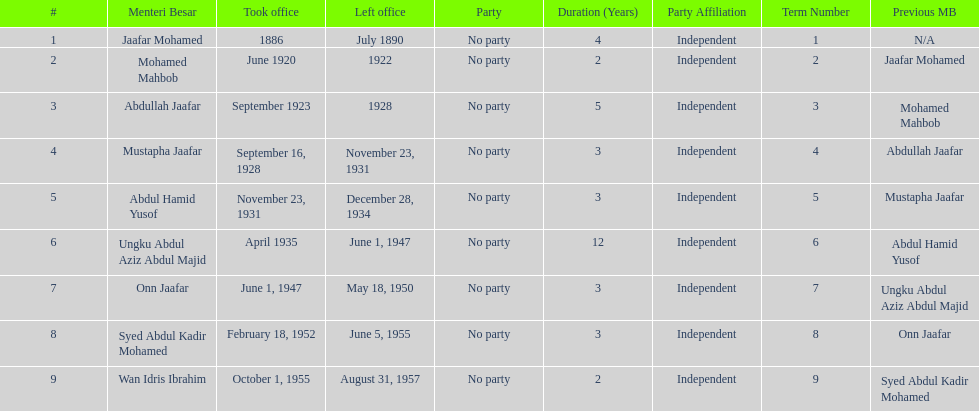Who took office after abdullah jaafar? Mustapha Jaafar. 